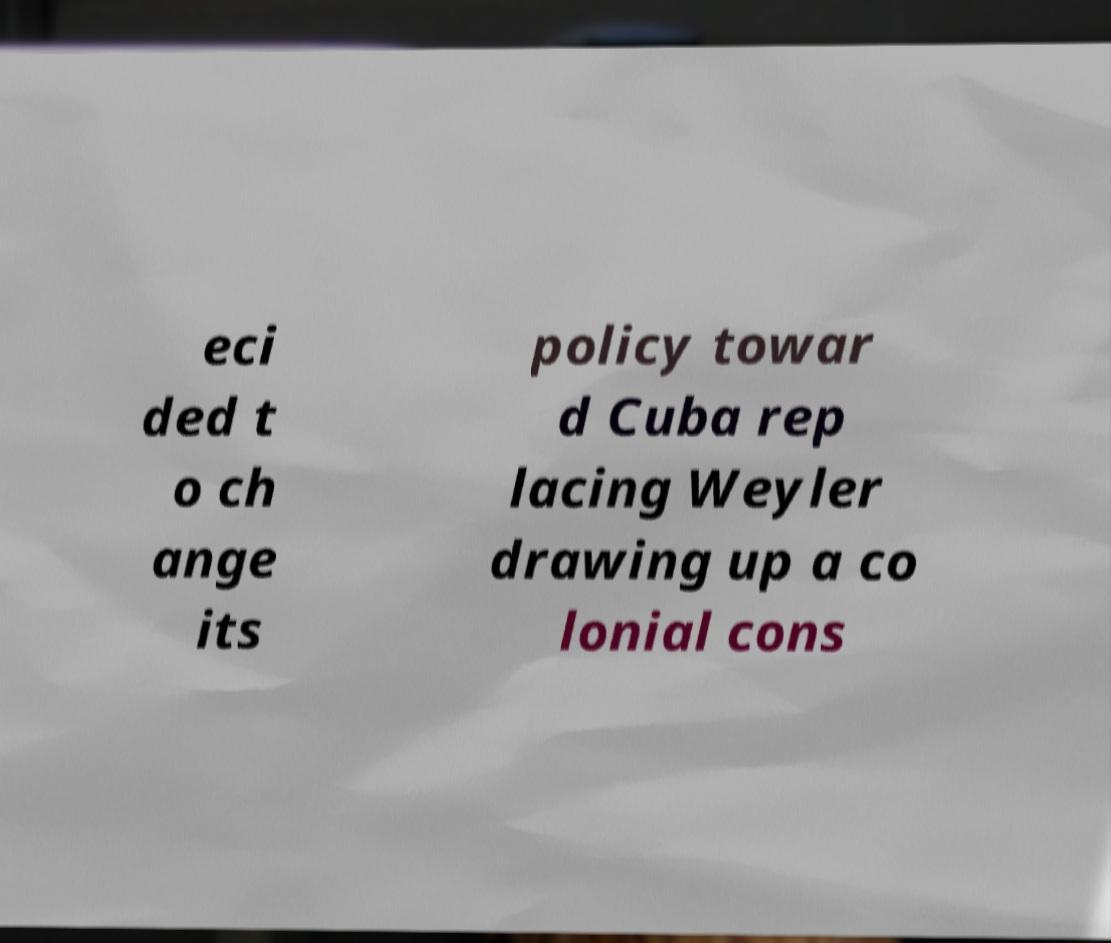Could you assist in decoding the text presented in this image and type it out clearly? eci ded t o ch ange its policy towar d Cuba rep lacing Weyler drawing up a co lonial cons 